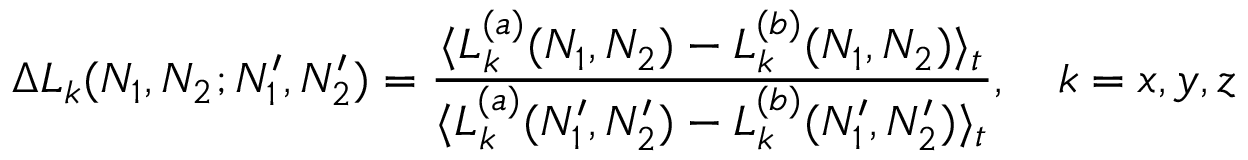<formula> <loc_0><loc_0><loc_500><loc_500>\Delta L _ { k } ( N _ { 1 } , N _ { 2 } ; N _ { 1 } ^ { \prime } , N _ { 2 } ^ { \prime } ) = \frac { \langle L _ { k } ^ { ( a ) } ( N _ { 1 } , N _ { 2 } ) - L _ { k } ^ { ( b ) } ( N _ { 1 } , N _ { 2 } ) \rangle _ { t } } { \langle L _ { k } ^ { ( a ) } ( N _ { 1 } ^ { \prime } , N _ { 2 } ^ { \prime } ) - L _ { k } ^ { ( b ) } ( N _ { 1 } ^ { \prime } , N _ { 2 } ^ { \prime } ) \rangle _ { t } } , \quad k = x , y , z</formula> 